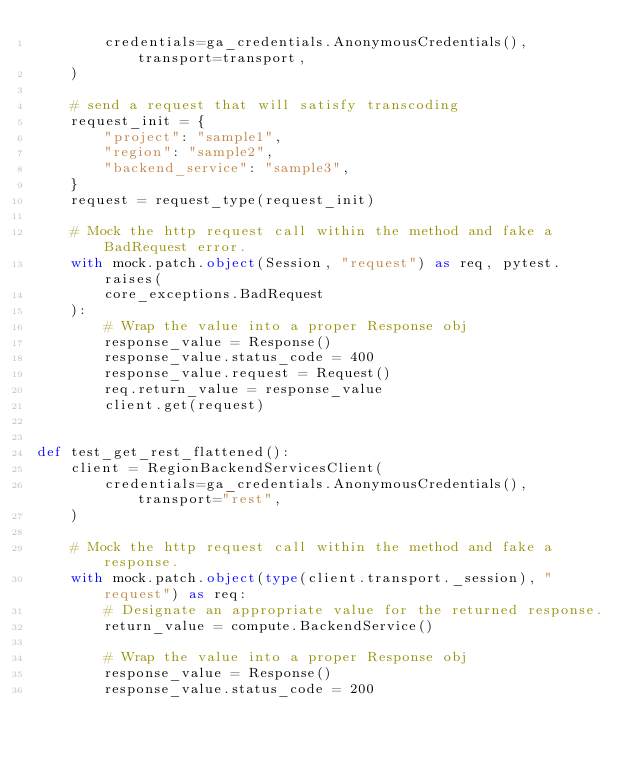<code> <loc_0><loc_0><loc_500><loc_500><_Python_>        credentials=ga_credentials.AnonymousCredentials(), transport=transport,
    )

    # send a request that will satisfy transcoding
    request_init = {
        "project": "sample1",
        "region": "sample2",
        "backend_service": "sample3",
    }
    request = request_type(request_init)

    # Mock the http request call within the method and fake a BadRequest error.
    with mock.patch.object(Session, "request") as req, pytest.raises(
        core_exceptions.BadRequest
    ):
        # Wrap the value into a proper Response obj
        response_value = Response()
        response_value.status_code = 400
        response_value.request = Request()
        req.return_value = response_value
        client.get(request)


def test_get_rest_flattened():
    client = RegionBackendServicesClient(
        credentials=ga_credentials.AnonymousCredentials(), transport="rest",
    )

    # Mock the http request call within the method and fake a response.
    with mock.patch.object(type(client.transport._session), "request") as req:
        # Designate an appropriate value for the returned response.
        return_value = compute.BackendService()

        # Wrap the value into a proper Response obj
        response_value = Response()
        response_value.status_code = 200</code> 